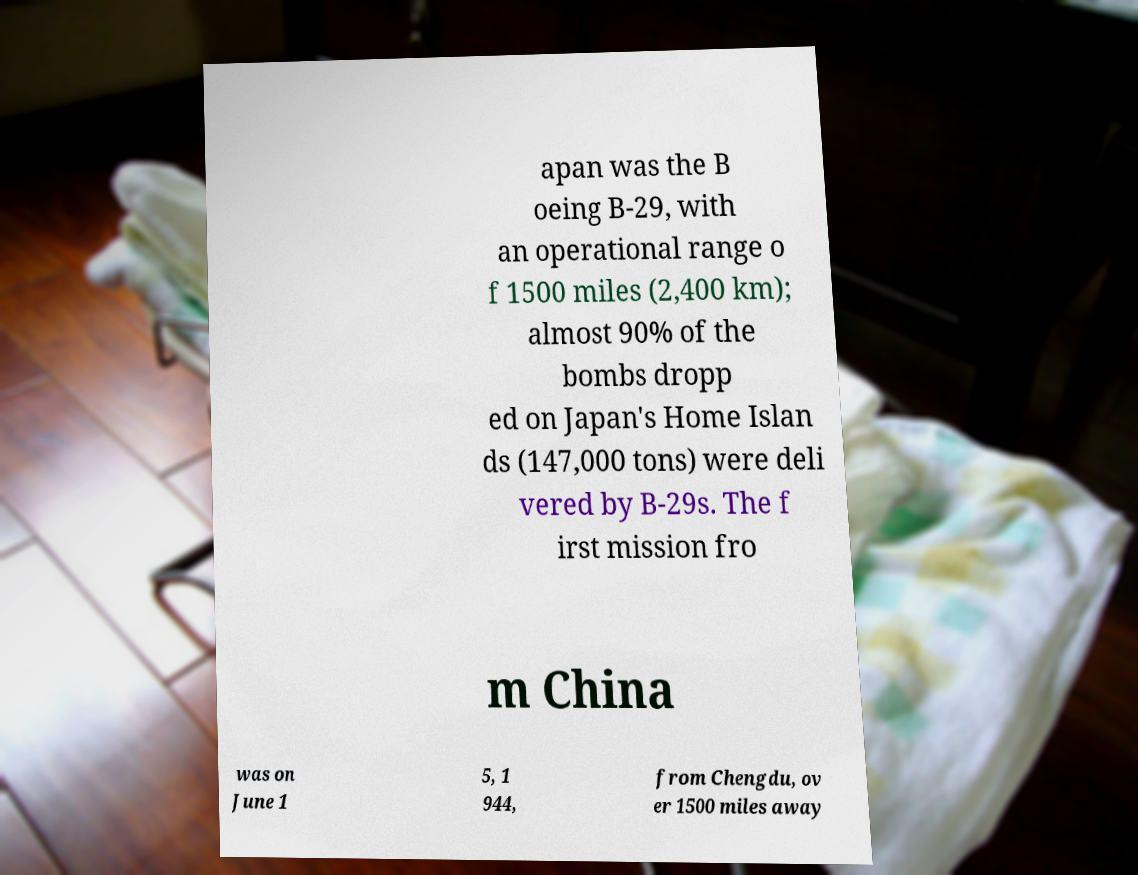What messages or text are displayed in this image? I need them in a readable, typed format. apan was the B oeing B-29, with an operational range o f 1500 miles (2,400 km); almost 90% of the bombs dropp ed on Japan's Home Islan ds (147,000 tons) were deli vered by B-29s. The f irst mission fro m China was on June 1 5, 1 944, from Chengdu, ov er 1500 miles away 